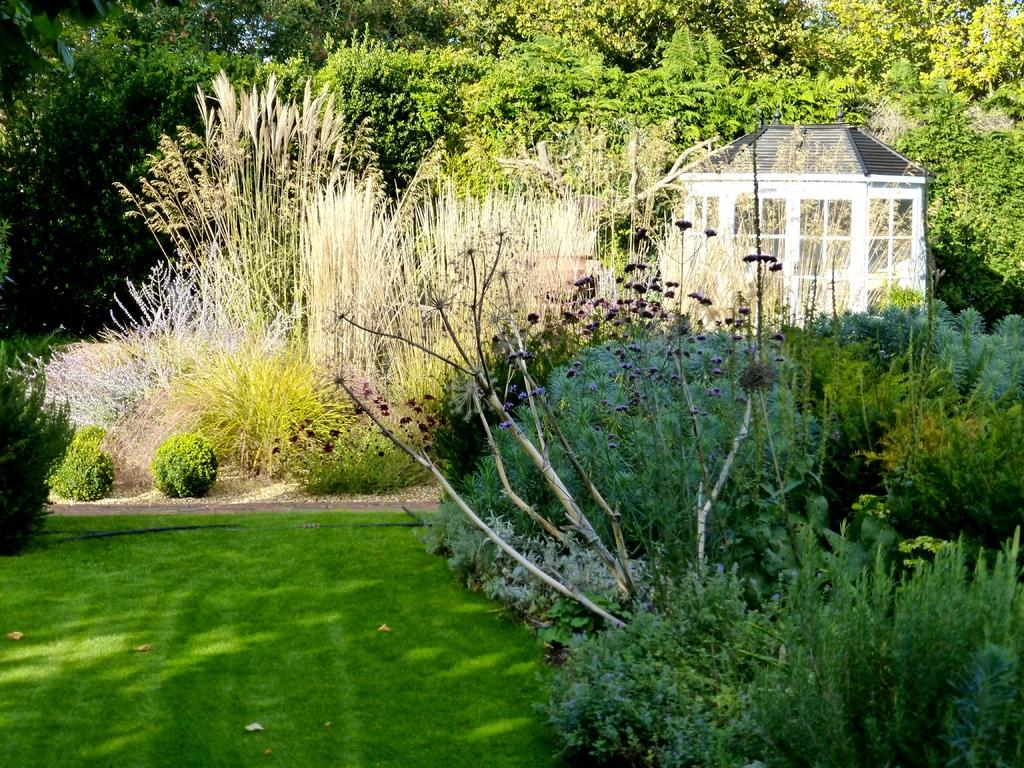What type of vegetation is present on the ground in the image? There are plants on the ground in the image. What type of ground cover can be seen in the image? There is grass visible in the image. What can be seen in the background of the image? There are trees in the background of the image. What type of structure is located on the right side of the image? There is a cabin on the right side of the image. What letter does the judge hold in the image? There is no judge or letter present in the image. What feeling does the cabin evoke in the image? The image does not convey feelings or emotions, and the cabin is a stationary structure. 